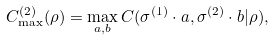Convert formula to latex. <formula><loc_0><loc_0><loc_500><loc_500>C ^ { ( 2 ) } _ { \max } ( \rho ) = \max _ { a , b } C ( \sigma ^ { ( 1 ) } \cdot a , \sigma ^ { ( 2 ) } \cdot b | \rho ) ,</formula> 